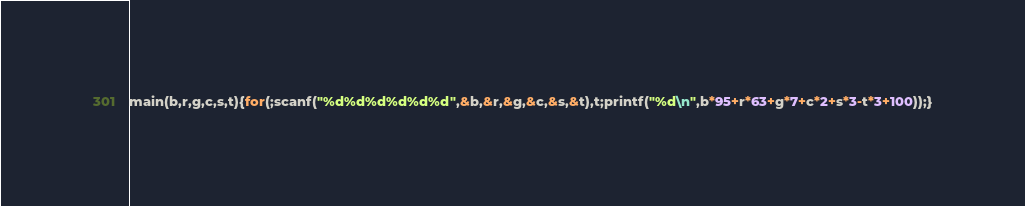<code> <loc_0><loc_0><loc_500><loc_500><_C_>main(b,r,g,c,s,t){for(;scanf("%d%d%d%d%d%d",&b,&r,&g,&c,&s,&t),t;printf("%d\n",b*95+r*63+g*7+c*2+s*3-t*3+100));}</code> 